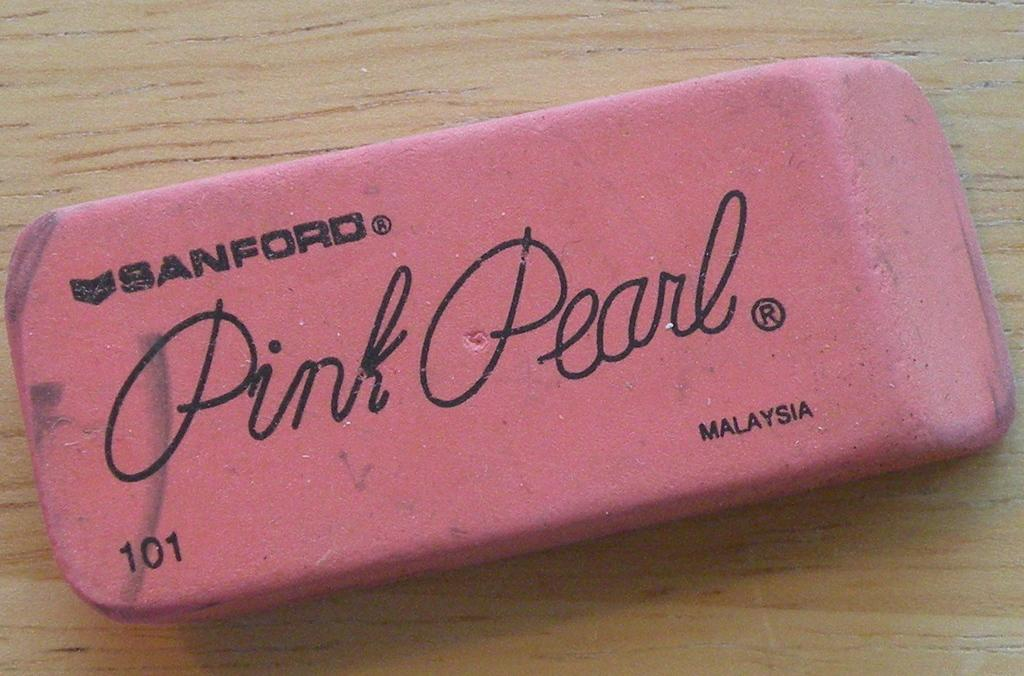What object is present in the image? There is an eraser in the image. Where is the eraser located? The eraser is placed on a table. What type of feast is being prepared on the table in the image? There is no feast or any indication of food preparation in the image; it only features an eraser placed on a table. 